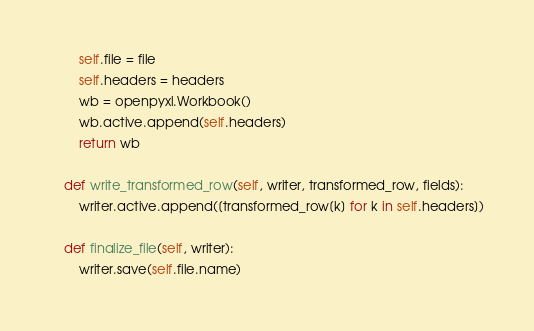<code> <loc_0><loc_0><loc_500><loc_500><_Python_>        self.file = file
        self.headers = headers
        wb = openpyxl.Workbook()
        wb.active.append(self.headers)
        return wb

    def write_transformed_row(self, writer, transformed_row, fields):
        writer.active.append([transformed_row[k] for k in self.headers])

    def finalize_file(self, writer):
        writer.save(self.file.name)
</code> 